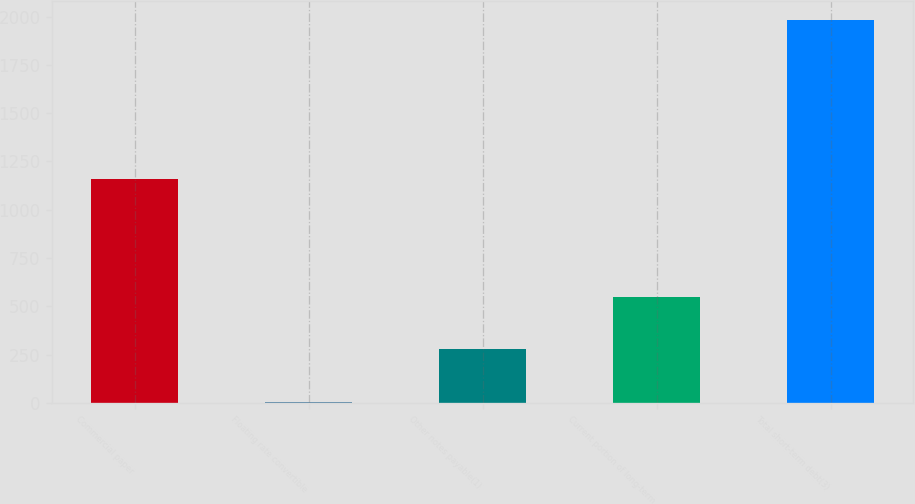Convert chart. <chart><loc_0><loc_0><loc_500><loc_500><bar_chart><fcel>Commercial paper<fcel>Floating rate convertible<fcel>Other notes payable(1)<fcel>Current portion of long-term<fcel>Total short-term debt(3)<nl><fcel>1157<fcel>2.84<fcel>278<fcel>547<fcel>1982<nl></chart> 